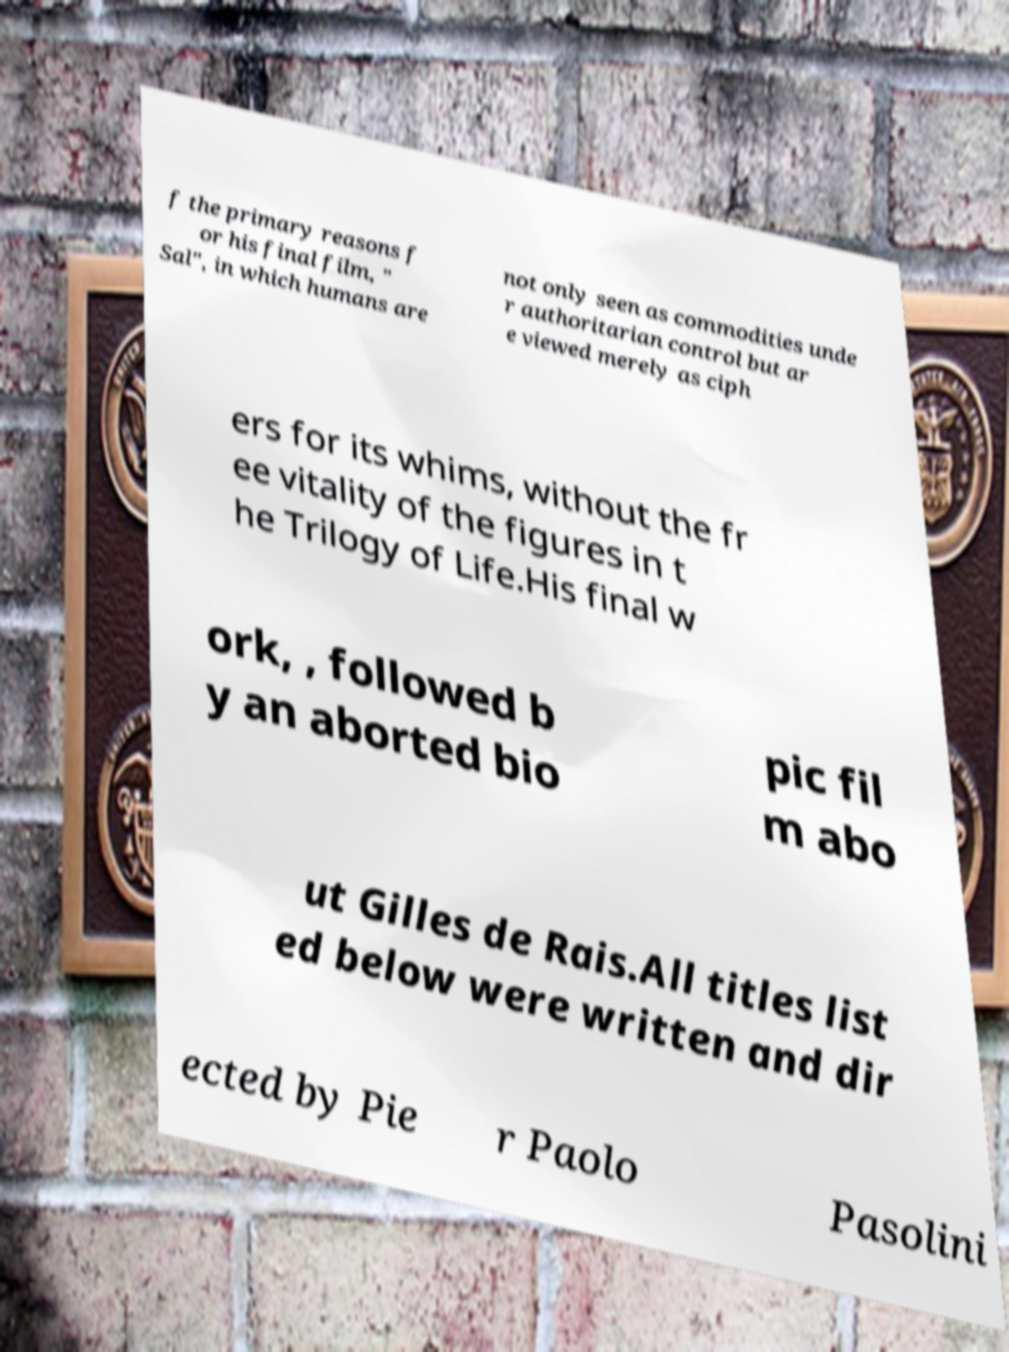There's text embedded in this image that I need extracted. Can you transcribe it verbatim? f the primary reasons f or his final film, " Sal", in which humans are not only seen as commodities unde r authoritarian control but ar e viewed merely as ciph ers for its whims, without the fr ee vitality of the figures in t he Trilogy of Life.His final w ork, , followed b y an aborted bio pic fil m abo ut Gilles de Rais.All titles list ed below were written and dir ected by Pie r Paolo Pasolini 